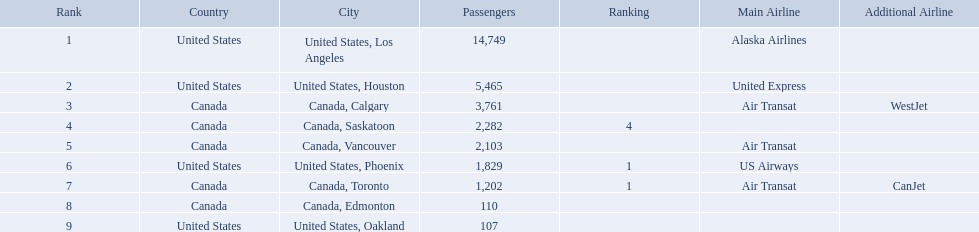What numbers are in the passengers column? 14,749, 5,465, 3,761, 2,282, 2,103, 1,829, 1,202, 110, 107. Which number is the lowest number in the passengers column? 107. What city is associated with this number? United States, Oakland. What are all the cities? United States, Los Angeles, United States, Houston, Canada, Calgary, Canada, Saskatoon, Canada, Vancouver, United States, Phoenix, Canada, Toronto, Canada, Edmonton, United States, Oakland. How many passengers do they service? 14,749, 5,465, 3,761, 2,282, 2,103, 1,829, 1,202, 110, 107. Which city, when combined with los angeles, totals nearly 19,000? Canada, Calgary. What cities do the planes fly to? United States, Los Angeles, United States, Houston, Canada, Calgary, Canada, Saskatoon, Canada, Vancouver, United States, Phoenix, Canada, Toronto, Canada, Edmonton, United States, Oakland. How many people are flying to phoenix, arizona? 1,829. What are the cities flown to? United States, Los Angeles, United States, Houston, Canada, Calgary, Canada, Saskatoon, Canada, Vancouver, United States, Phoenix, Canada, Toronto, Canada, Edmonton, United States, Oakland. What number of passengers did pheonix have? 1,829. 